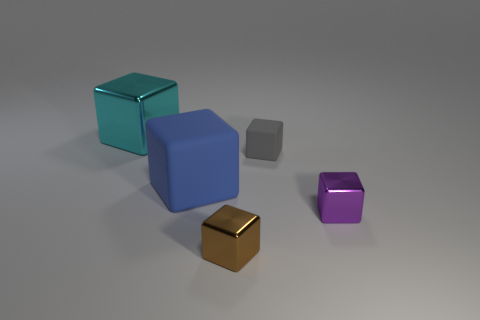What colors are the cubes shown in the image? The image shows cubes in the colors of blue, teal, gray, gold, and purple. 